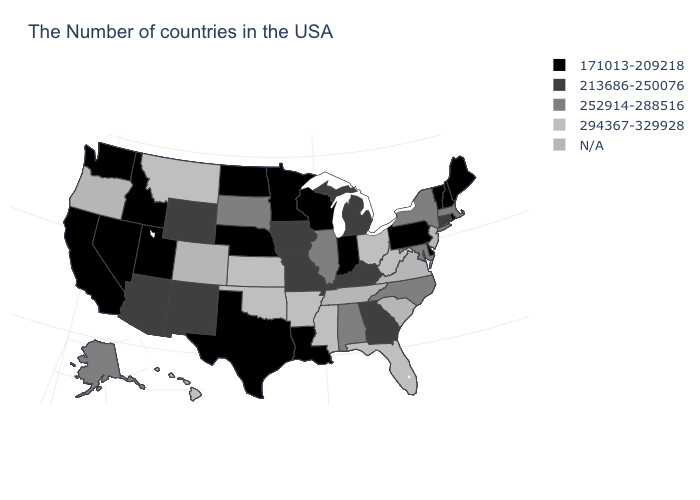Is the legend a continuous bar?
Give a very brief answer. No. Does the map have missing data?
Give a very brief answer. Yes. Name the states that have a value in the range 294367-329928?
Write a very short answer. West Virginia, Ohio, Florida, Mississippi, Arkansas, Kansas, Oklahoma, Montana, Hawaii. What is the value of New Hampshire?
Be succinct. 171013-209218. Name the states that have a value in the range 294367-329928?
Keep it brief. West Virginia, Ohio, Florida, Mississippi, Arkansas, Kansas, Oklahoma, Montana, Hawaii. Which states hav the highest value in the West?
Keep it brief. Montana, Hawaii. Does Pennsylvania have the lowest value in the USA?
Quick response, please. Yes. What is the value of Utah?
Write a very short answer. 171013-209218. Does Idaho have the highest value in the USA?
Be succinct. No. Name the states that have a value in the range 171013-209218?
Keep it brief. Maine, Rhode Island, New Hampshire, Vermont, Delaware, Pennsylvania, Indiana, Wisconsin, Louisiana, Minnesota, Nebraska, Texas, North Dakota, Utah, Idaho, Nevada, California, Washington. Which states have the lowest value in the USA?
Short answer required. Maine, Rhode Island, New Hampshire, Vermont, Delaware, Pennsylvania, Indiana, Wisconsin, Louisiana, Minnesota, Nebraska, Texas, North Dakota, Utah, Idaho, Nevada, California, Washington. What is the value of Montana?
Be succinct. 294367-329928. Does Delaware have the lowest value in the South?
Give a very brief answer. Yes. What is the value of Nevada?
Short answer required. 171013-209218. 